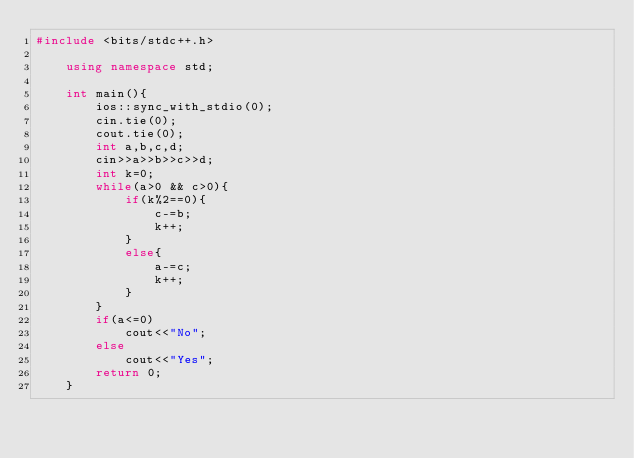<code> <loc_0><loc_0><loc_500><loc_500><_C++_>#include <bits/stdc++.h>

    using namespace std;

    int main(){
        ios::sync_with_stdio(0);
        cin.tie(0);
        cout.tie(0);
        int a,b,c,d;
        cin>>a>>b>>c>>d;
        int k=0;
        while(a>0 && c>0){
            if(k%2==0){
                c-=b;
                k++;
            }
            else{
                a-=c;
                k++;
            }
        }
        if(a<=0)
            cout<<"No";
        else
            cout<<"Yes";
        return 0;
    }
</code> 